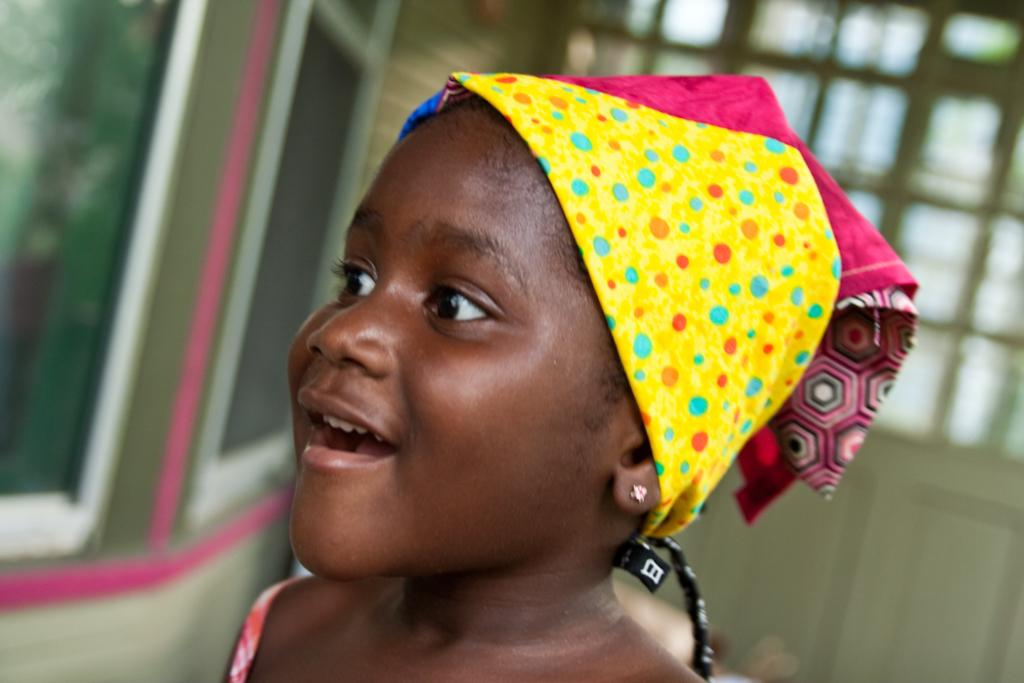Who is the main subject in the image? There is a girl in the image. What is the girl wearing on her head? The girl is wearing a cap. What is the girl's facial expression in the image? The girl is smiling. What is the girl doing in the image? The girl is watching something. Can you describe the background of the image? The background of the image is blurred. What type of gun is the girl holding in the image? There is no gun present in the image; the girl is only wearing a cap and smiling. 